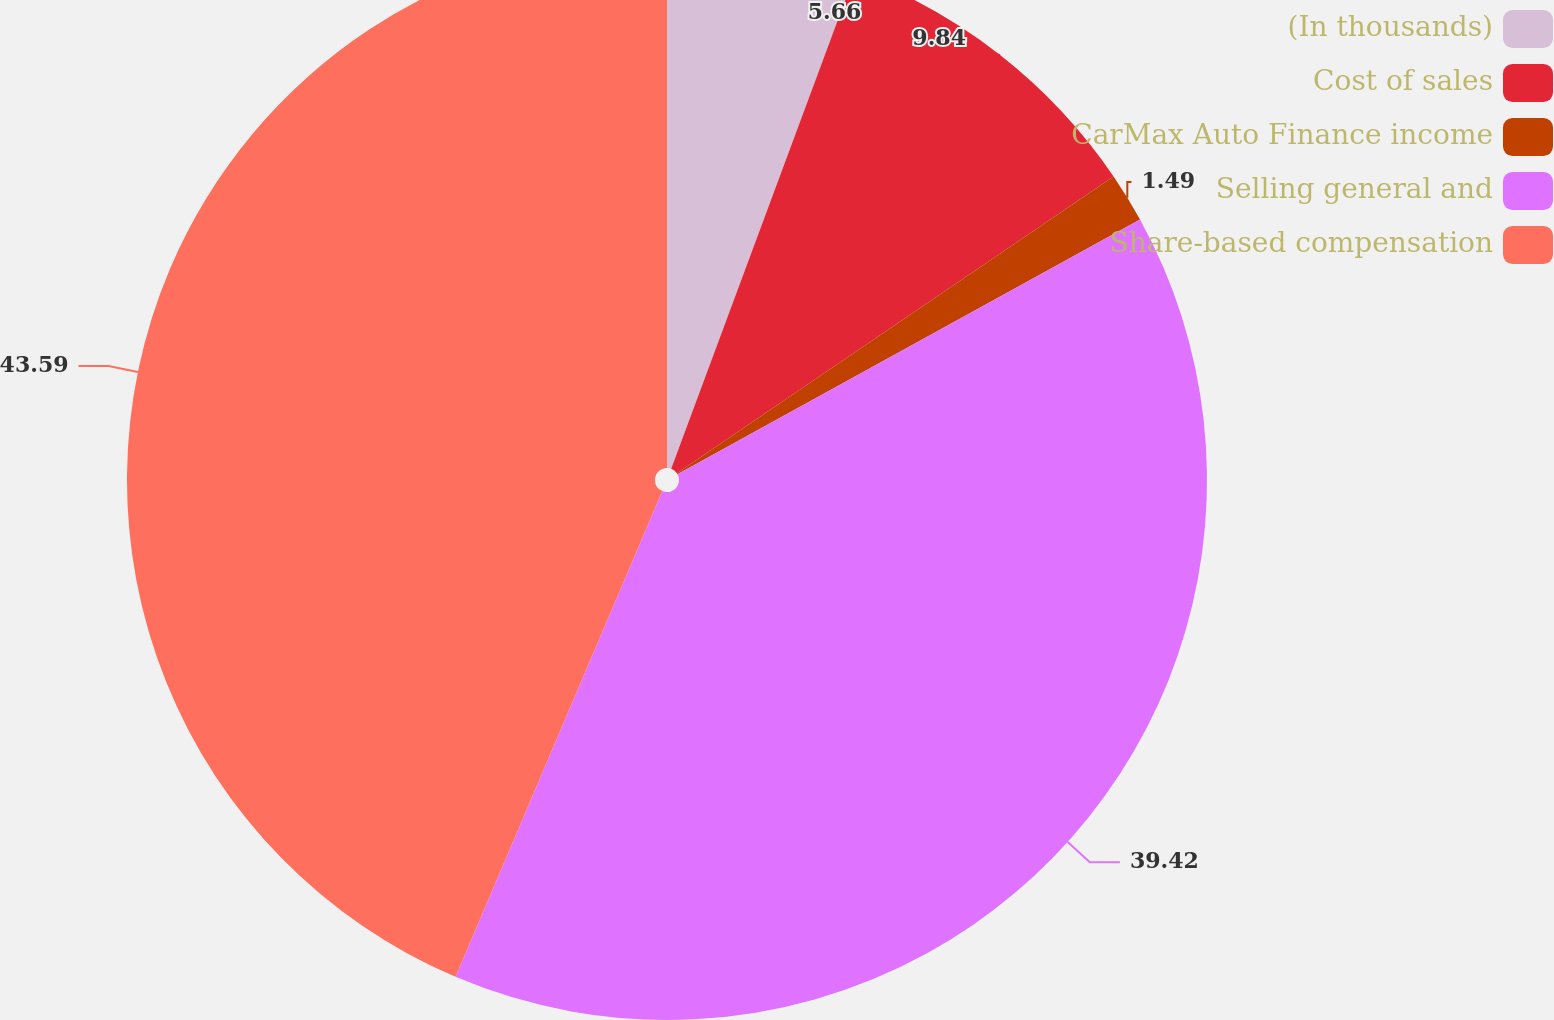Convert chart to OTSL. <chart><loc_0><loc_0><loc_500><loc_500><pie_chart><fcel>(In thousands)<fcel>Cost of sales<fcel>CarMax Auto Finance income<fcel>Selling general and<fcel>Share-based compensation<nl><fcel>5.66%<fcel>9.84%<fcel>1.49%<fcel>39.42%<fcel>43.6%<nl></chart> 